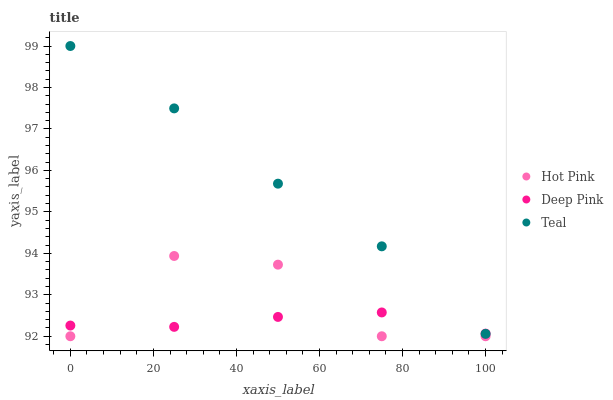Does Deep Pink have the minimum area under the curve?
Answer yes or no. Yes. Does Teal have the maximum area under the curve?
Answer yes or no. Yes. Does Teal have the minimum area under the curve?
Answer yes or no. No. Does Deep Pink have the maximum area under the curve?
Answer yes or no. No. Is Deep Pink the smoothest?
Answer yes or no. Yes. Is Hot Pink the roughest?
Answer yes or no. Yes. Is Teal the smoothest?
Answer yes or no. No. Is Teal the roughest?
Answer yes or no. No. Does Hot Pink have the lowest value?
Answer yes or no. Yes. Does Teal have the lowest value?
Answer yes or no. No. Does Teal have the highest value?
Answer yes or no. Yes. Does Deep Pink have the highest value?
Answer yes or no. No. Is Hot Pink less than Teal?
Answer yes or no. Yes. Is Teal greater than Hot Pink?
Answer yes or no. Yes. Does Hot Pink intersect Deep Pink?
Answer yes or no. Yes. Is Hot Pink less than Deep Pink?
Answer yes or no. No. Is Hot Pink greater than Deep Pink?
Answer yes or no. No. Does Hot Pink intersect Teal?
Answer yes or no. No. 